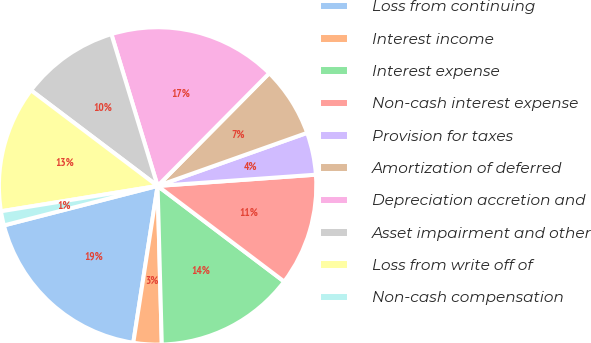Convert chart. <chart><loc_0><loc_0><loc_500><loc_500><pie_chart><fcel>Loss from continuing<fcel>Interest income<fcel>Interest expense<fcel>Non-cash interest expense<fcel>Provision for taxes<fcel>Amortization of deferred<fcel>Depreciation accretion and<fcel>Asset impairment and other<fcel>Loss from write off of<fcel>Non-cash compensation<nl><fcel>18.55%<fcel>2.87%<fcel>14.28%<fcel>11.43%<fcel>4.3%<fcel>7.15%<fcel>17.13%<fcel>10.0%<fcel>12.85%<fcel>1.45%<nl></chart> 